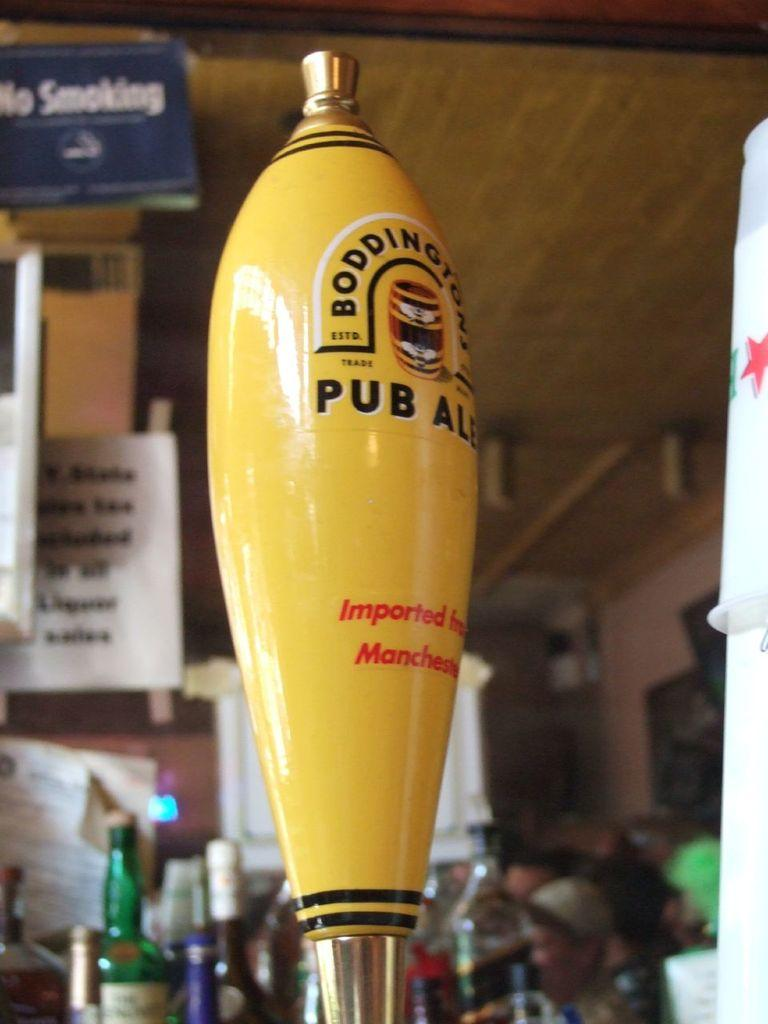Provide a one-sentence caption for the provided image. Yes, Bondingtons Pub Ale is on tap, but there is no smoking allowed. 